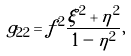<formula> <loc_0><loc_0><loc_500><loc_500>g _ { 2 2 } = f ^ { 2 } \frac { \xi ^ { 2 } + \eta ^ { 2 } } { 1 - \eta ^ { 2 } } ,</formula> 